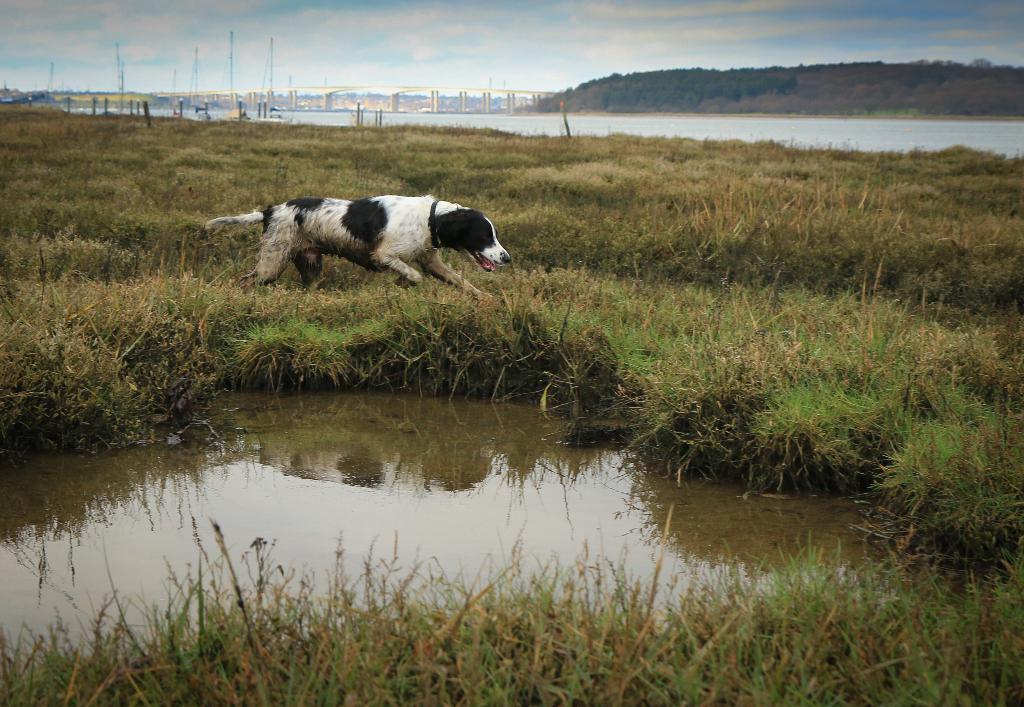In one or two sentences, can you explain what this image depicts? In this picture we can see black and white dog running on the grass ground. In the front we can see small pond water. Behind there is a bridge and hilly area. On the top we can see sky and clouds. 